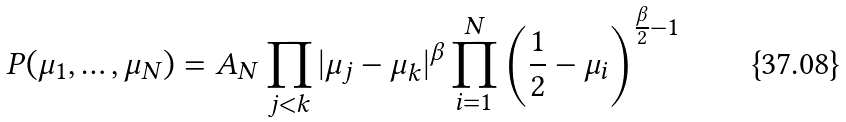<formula> <loc_0><loc_0><loc_500><loc_500>P ( \mu _ { 1 } , \dots , \mu _ { N } ) = A _ { N } \prod _ { j < k } | \mu _ { j } - \mu _ { k } | ^ { \beta } \prod _ { i = 1 } ^ { N } \left ( \frac { 1 } { 2 } - \mu _ { i } \right ) ^ { \frac { \beta } { 2 } - 1 }</formula> 